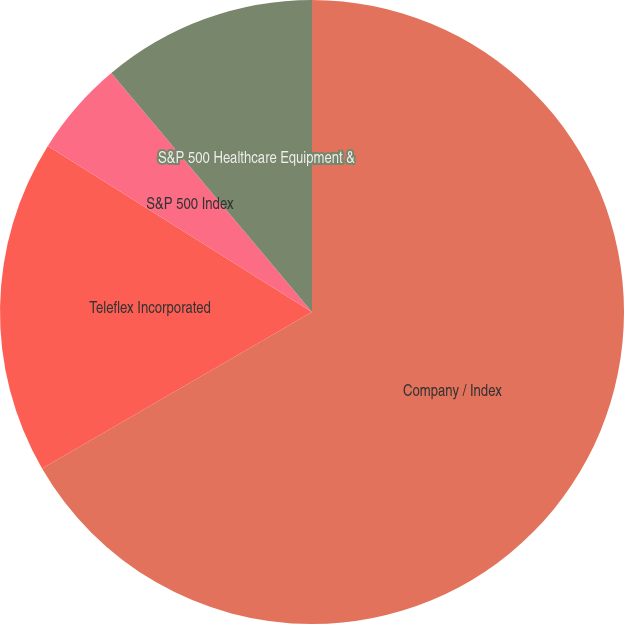Convert chart to OTSL. <chart><loc_0><loc_0><loc_500><loc_500><pie_chart><fcel>Company / Index<fcel>Teleflex Incorporated<fcel>S&P 500 Index<fcel>S&P 500 Healthcare Equipment &<nl><fcel>66.64%<fcel>17.29%<fcel>4.95%<fcel>11.12%<nl></chart> 